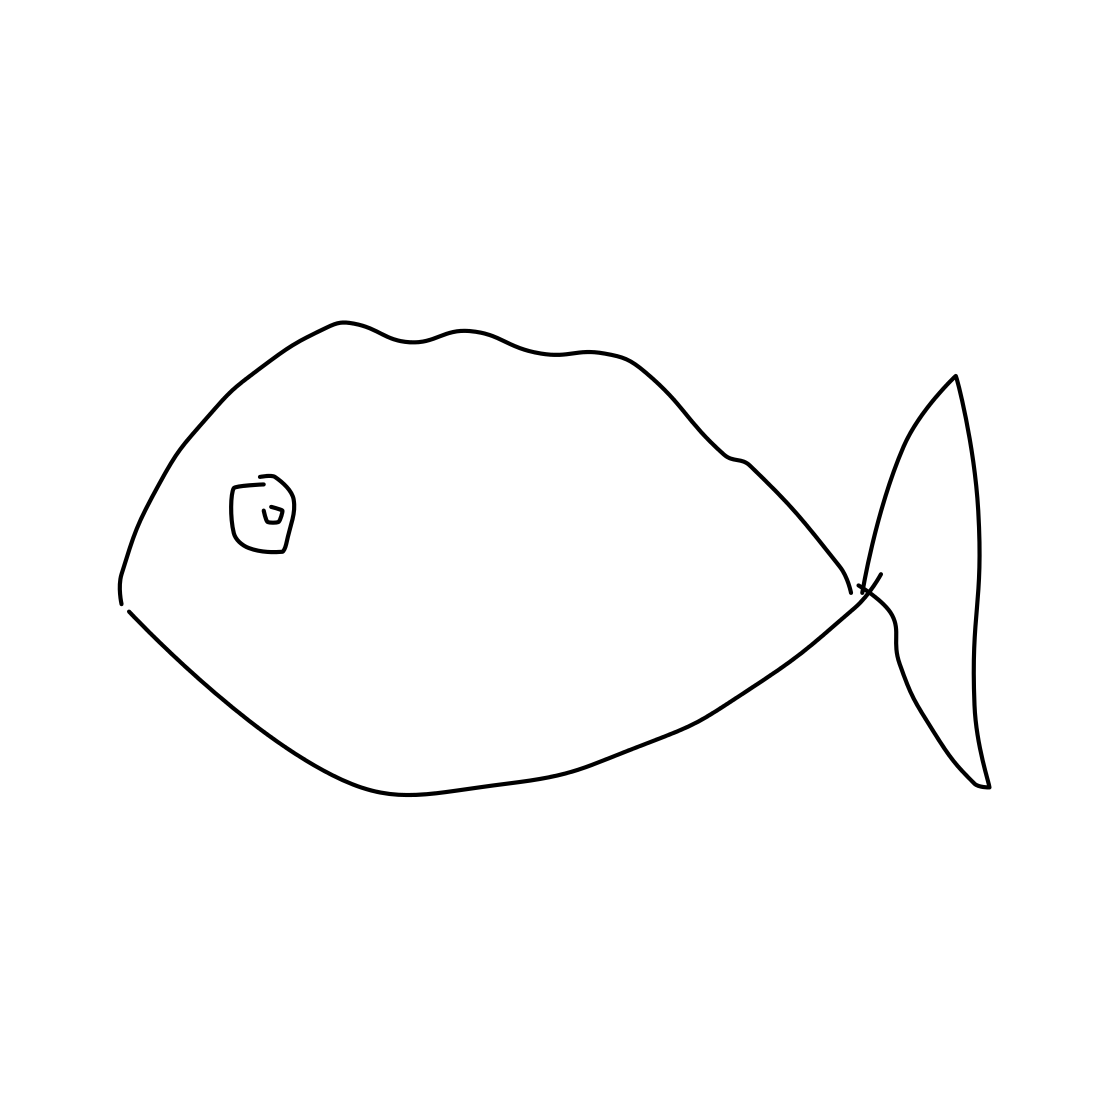What could be the significance of the single detail inside the fish? The single detail inside the fish, which appears to be a square with a symbol, could represent a unique feature or a branding mark. In the context of minimalistic art, such a specific detail can suggest a focal point for the viewer's attention or even convey a message about the fish's identity or origin. 